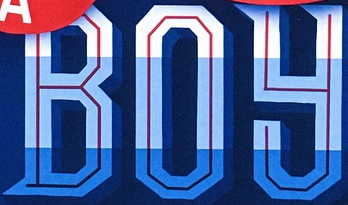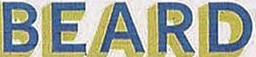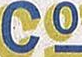Read the text from these images in sequence, separated by a semicolon. BOY; BEARD; Co 